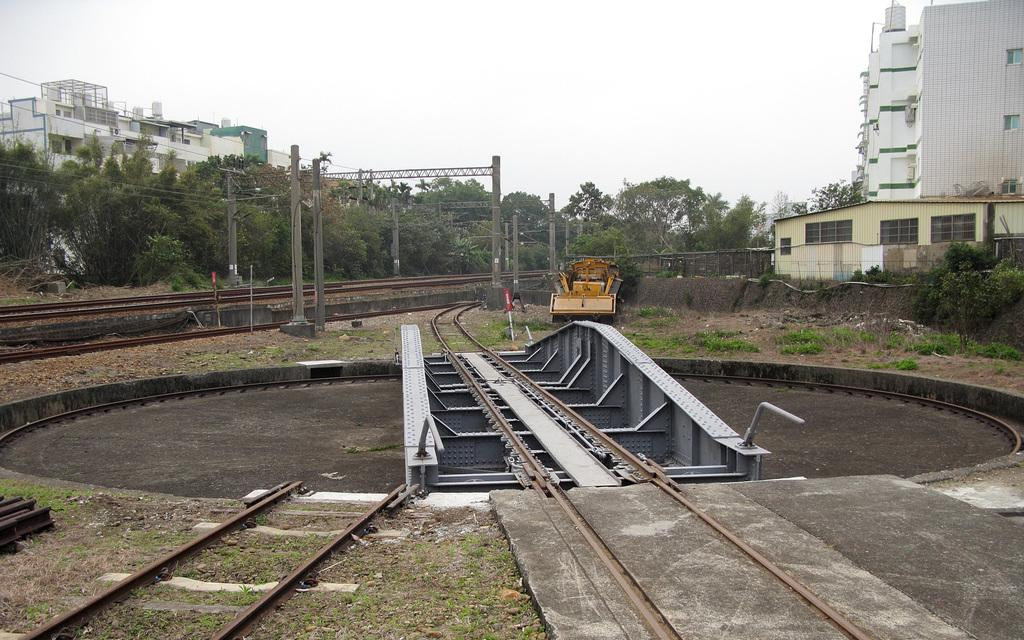What type of transportation infrastructure is visible in the image? There are railway tracks in the image. What type of machinery is present in the image? There is a crane in the image. What type of vertical structures are in the image? There are poles in the image. What type of natural vegetation is visible in the image? There are trees in the image. What type of man-made structures are visible in the image? There are buildings in the image. What type of juice is being extracted from the vein in the image? There is no juice or vein present in the image. How many trains are visible on the railway tracks in the image? There are no trains visible on the railway tracks in the image. 